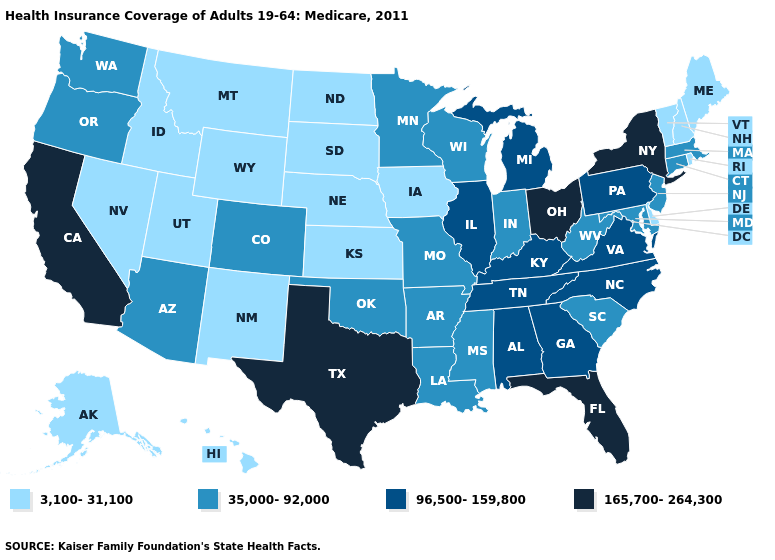Which states have the lowest value in the MidWest?
Short answer required. Iowa, Kansas, Nebraska, North Dakota, South Dakota. Does Florida have the highest value in the USA?
Keep it brief. Yes. Does the first symbol in the legend represent the smallest category?
Be succinct. Yes. What is the lowest value in the USA?
Be succinct. 3,100-31,100. What is the highest value in the USA?
Write a very short answer. 165,700-264,300. Name the states that have a value in the range 35,000-92,000?
Give a very brief answer. Arizona, Arkansas, Colorado, Connecticut, Indiana, Louisiana, Maryland, Massachusetts, Minnesota, Mississippi, Missouri, New Jersey, Oklahoma, Oregon, South Carolina, Washington, West Virginia, Wisconsin. What is the value of Massachusetts?
Give a very brief answer. 35,000-92,000. Name the states that have a value in the range 35,000-92,000?
Concise answer only. Arizona, Arkansas, Colorado, Connecticut, Indiana, Louisiana, Maryland, Massachusetts, Minnesota, Mississippi, Missouri, New Jersey, Oklahoma, Oregon, South Carolina, Washington, West Virginia, Wisconsin. Does Delaware have a lower value than Nevada?
Be succinct. No. Among the states that border South Dakota , which have the highest value?
Quick response, please. Minnesota. Name the states that have a value in the range 3,100-31,100?
Answer briefly. Alaska, Delaware, Hawaii, Idaho, Iowa, Kansas, Maine, Montana, Nebraska, Nevada, New Hampshire, New Mexico, North Dakota, Rhode Island, South Dakota, Utah, Vermont, Wyoming. Which states have the lowest value in the USA?
Give a very brief answer. Alaska, Delaware, Hawaii, Idaho, Iowa, Kansas, Maine, Montana, Nebraska, Nevada, New Hampshire, New Mexico, North Dakota, Rhode Island, South Dakota, Utah, Vermont, Wyoming. Name the states that have a value in the range 3,100-31,100?
Concise answer only. Alaska, Delaware, Hawaii, Idaho, Iowa, Kansas, Maine, Montana, Nebraska, Nevada, New Hampshire, New Mexico, North Dakota, Rhode Island, South Dakota, Utah, Vermont, Wyoming. What is the value of Oklahoma?
Concise answer only. 35,000-92,000. Does Maine have the highest value in the Northeast?
Concise answer only. No. 